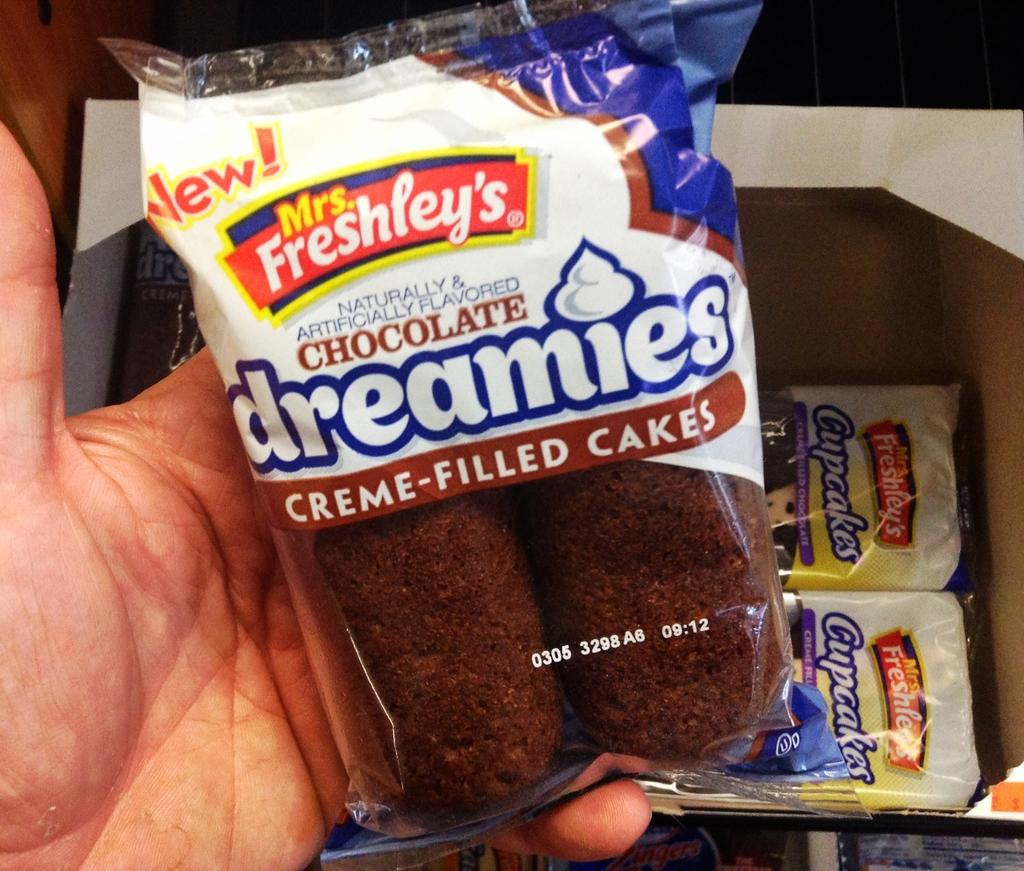<image>
Summarize the visual content of the image. a creme filled cake that is in a package 